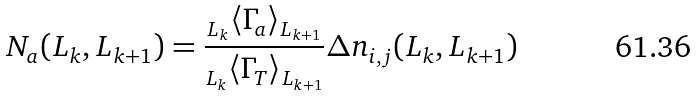Convert formula to latex. <formula><loc_0><loc_0><loc_500><loc_500>N _ { a } ( L _ { k } , L _ { k + 1 } ) = \frac { _ { L _ { k } } \langle \Gamma _ { a } \rangle _ { L _ { k + 1 } } } { _ { L _ { k } } \langle \Gamma _ { T } \rangle _ { L _ { k + 1 } } } \Delta n _ { i , j } ( L _ { k } , L _ { k + 1 } )</formula> 